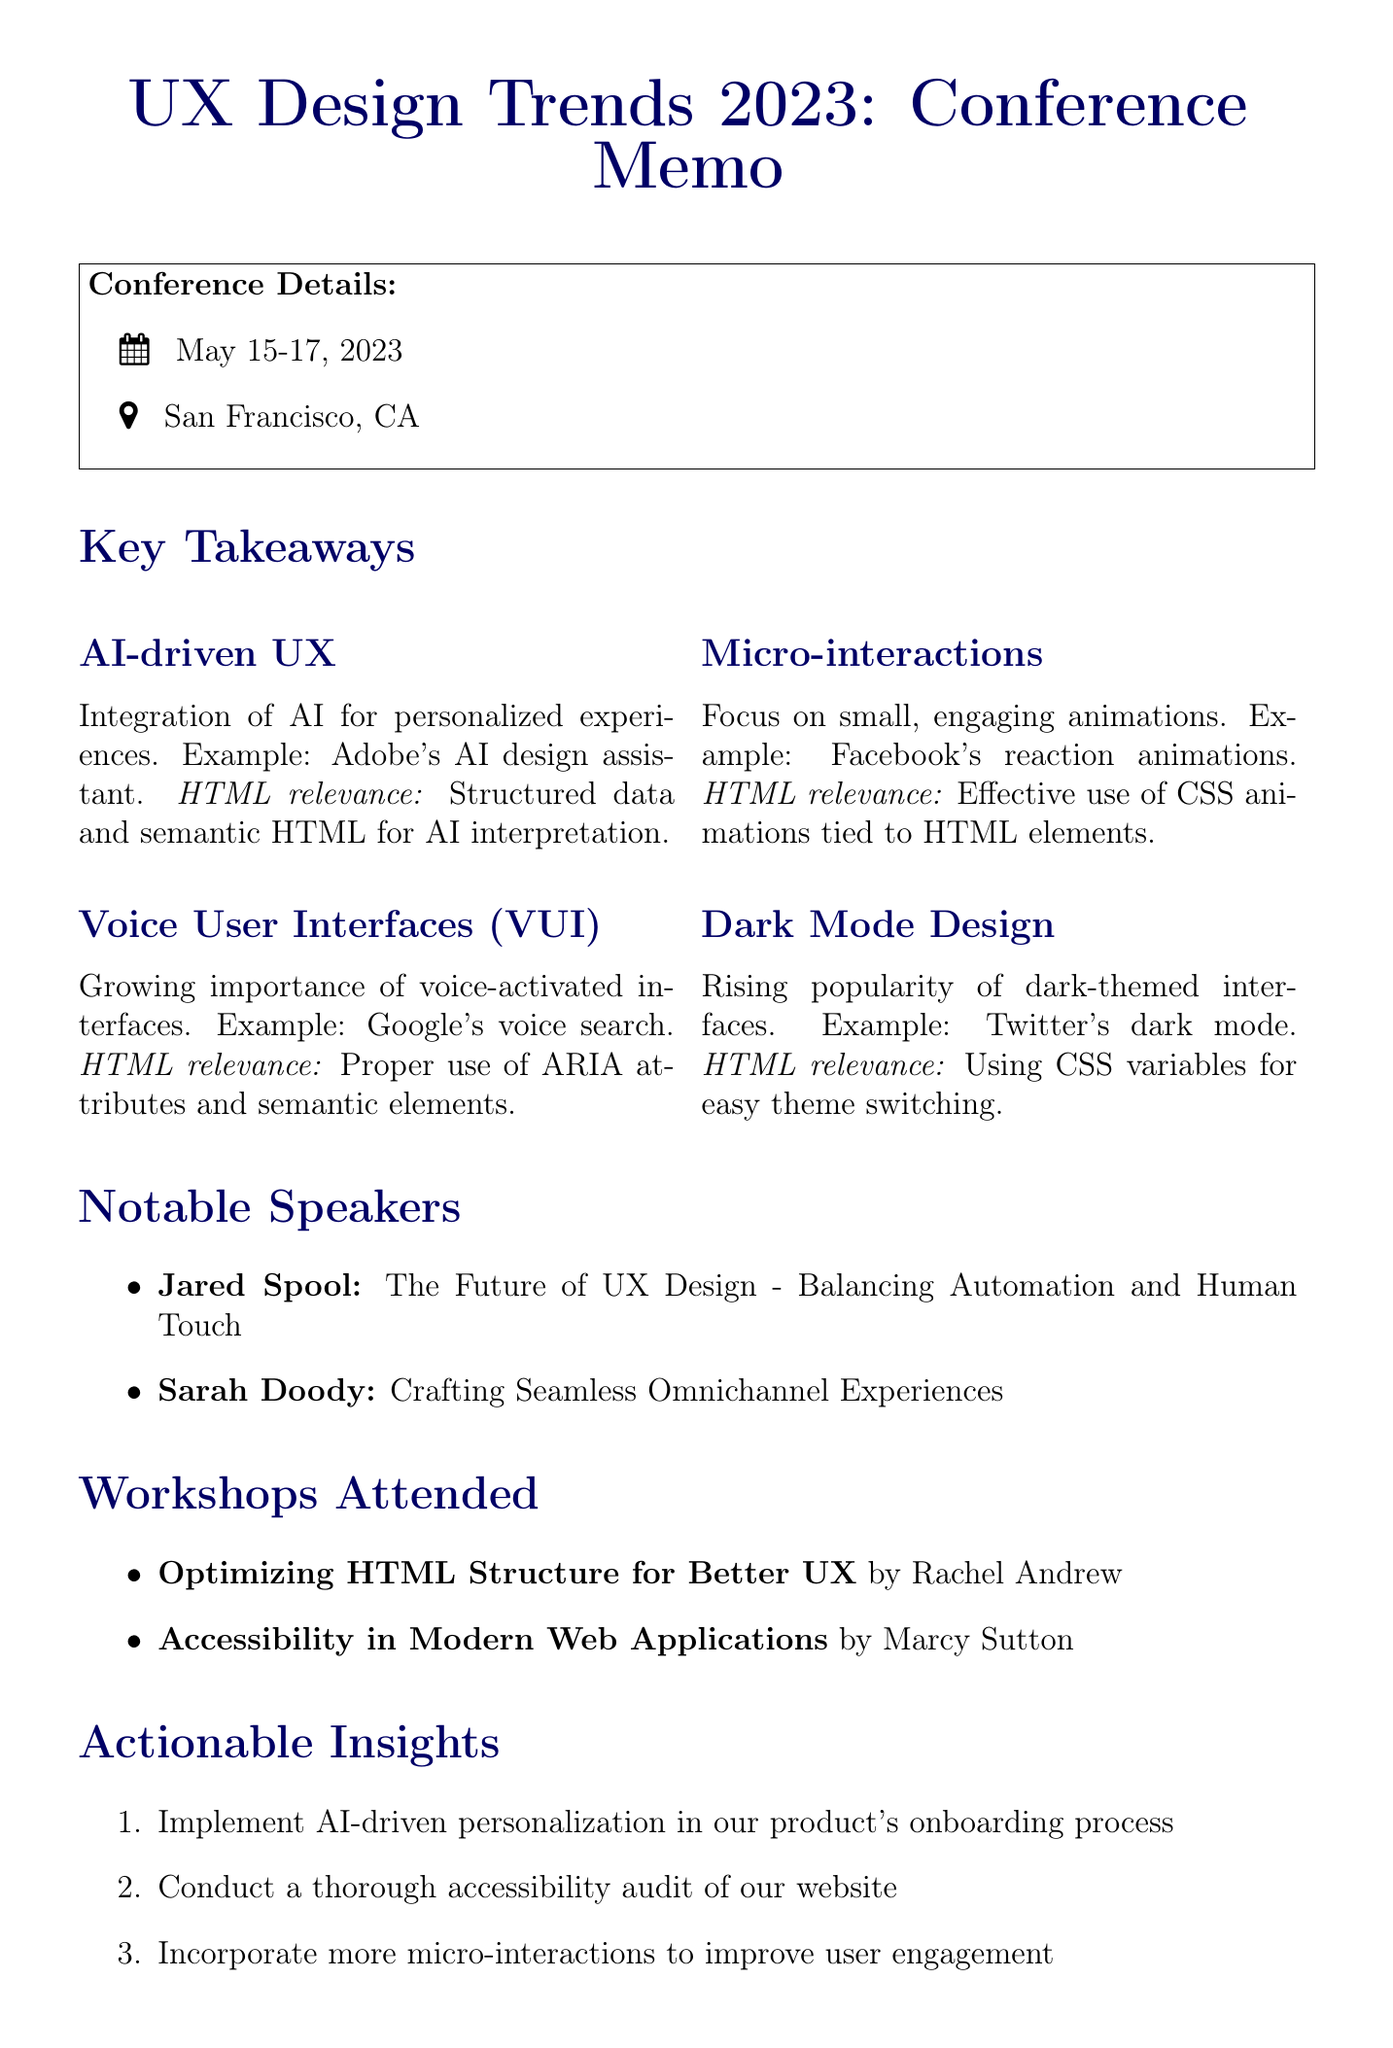what was the date of the conference? The conference took place from May 15 to May 17, 2023.
Answer: May 15-17, 2023 where was the conference held? The location of the conference is specified in the document.
Answer: San Francisco, CA who was the instructor of the workshop on optimizing HTML structure? The document lists the instructor's name for this specific workshop.
Answer: Rachel Andrew which trend focuses on small engaging animations? The document describes trends and one of them relates to engaging animations.
Answer: Micro-interactions what is one key point emphasized by Jared Spool? The document mentions key points discussed by notable speakers, including Jared Spool's key point.
Answer: Human-centered design principles what type of design is mentioned as rising in popularity? The document identifies trends in UX design, one of which is discussed in terms of popularity.
Answer: Dark Mode Design what was a workshop topic attended related to accessibility? The document explicitly lists the workshops attended by the UX designer, including relevant topics.
Answer: Accessibility in Modern Web Applications how many actionable insights are listed in the document? The document provides a list of actionable insights which can be counted.
Answer: Four 